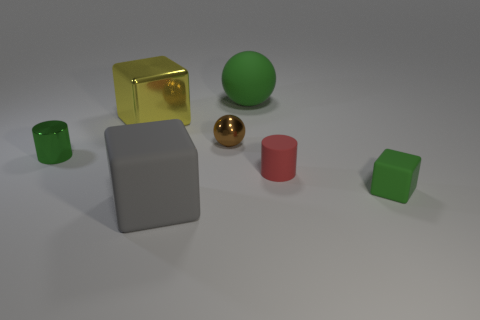How do the textures and materials of the objects contrast with each other? The image depicts an intriguing mix of textures and materials. The grey cube has a matte, smooth finish, which contrasts sharply against the shiny, reflective surface of the golden sphere. The green objects seem to have a slightly roughened texture suggesting a rubber material. The brown ball seems to have a muted, less reflective surface compared to the gold sphere. The red cylinder looks smooth, possibly plastic, while the small green cylinder's texture is less discernible. These differing textures and materials catch light and cast shadows uniquely, creating a visually captivating scene. 